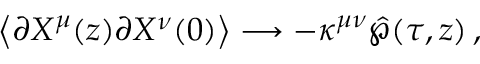Convert formula to latex. <formula><loc_0><loc_0><loc_500><loc_500>\left < \partial X ^ { \mu } ( z ) \partial X ^ { \nu } ( 0 ) \right > \longrightarrow - \kappa ^ { \mu \nu } \hat { \wp } ( \tau , z ) \, ,</formula> 